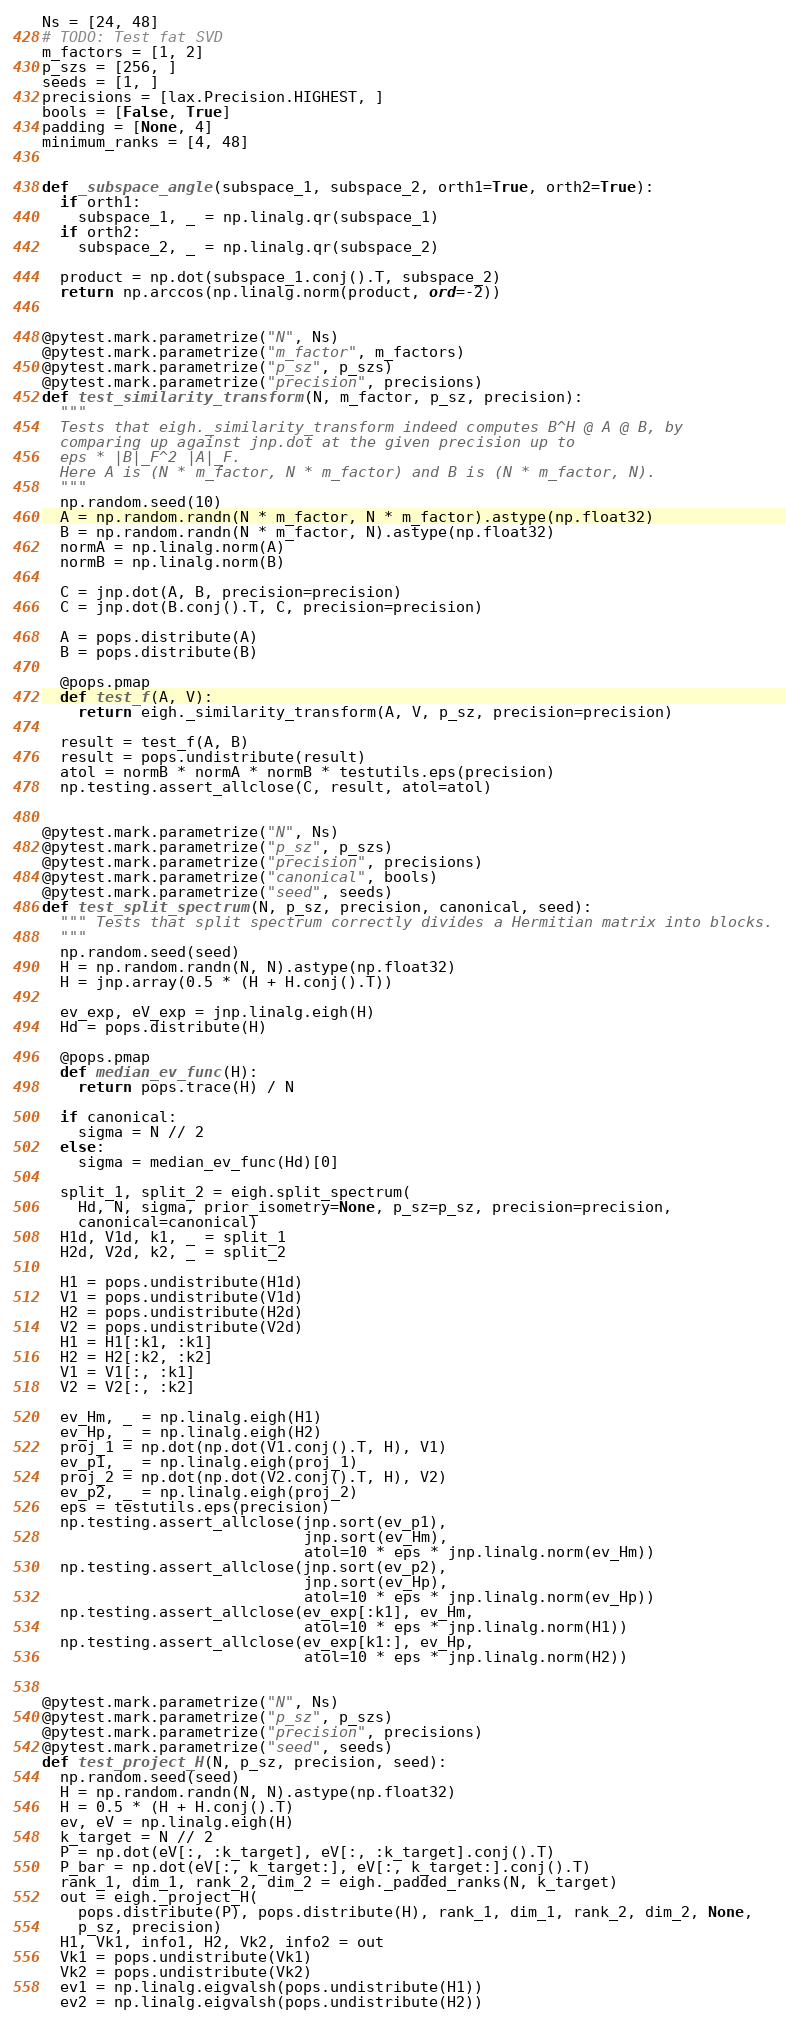<code> <loc_0><loc_0><loc_500><loc_500><_Python_>Ns = [24, 48]
# TODO: Test fat SVD
m_factors = [1, 2]
p_szs = [256, ]
seeds = [1, ]
precisions = [lax.Precision.HIGHEST, ]
bools = [False, True]
padding = [None, 4]
minimum_ranks = [4, 48]


def _subspace_angle(subspace_1, subspace_2, orth1=True, orth2=True):
  if orth1:
    subspace_1, _ = np.linalg.qr(subspace_1)
  if orth2:
    subspace_2, _ = np.linalg.qr(subspace_2)

  product = np.dot(subspace_1.conj().T, subspace_2)
  return np.arccos(np.linalg.norm(product, ord=-2))


@pytest.mark.parametrize("N", Ns)
@pytest.mark.parametrize("m_factor", m_factors)
@pytest.mark.parametrize("p_sz", p_szs)
@pytest.mark.parametrize("precision", precisions)
def test_similarity_transform(N, m_factor, p_sz, precision):
  """
  Tests that eigh._similarity_transform indeed computes B^H @ A @ B, by
  comparing up against jnp.dot at the given precision up to
  eps * |B|_F^2 |A|_F.
  Here A is (N * m_factor, N * m_factor) and B is (N * m_factor, N).
  """
  np.random.seed(10)
  A = np.random.randn(N * m_factor, N * m_factor).astype(np.float32)
  B = np.random.randn(N * m_factor, N).astype(np.float32)
  normA = np.linalg.norm(A)
  normB = np.linalg.norm(B)

  C = jnp.dot(A, B, precision=precision)
  C = jnp.dot(B.conj().T, C, precision=precision)

  A = pops.distribute(A)
  B = pops.distribute(B)

  @pops.pmap
  def test_f(A, V):
    return eigh._similarity_transform(A, V, p_sz, precision=precision)

  result = test_f(A, B)
  result = pops.undistribute(result)
  atol = normB * normA * normB * testutils.eps(precision)
  np.testing.assert_allclose(C, result, atol=atol)


@pytest.mark.parametrize("N", Ns)
@pytest.mark.parametrize("p_sz", p_szs)
@pytest.mark.parametrize("precision", precisions)
@pytest.mark.parametrize("canonical", bools)
@pytest.mark.parametrize("seed", seeds)
def test_split_spectrum(N, p_sz, precision, canonical, seed):
  """ Tests that split spectrum correctly divides a Hermitian matrix into blocks.
  """
  np.random.seed(seed)
  H = np.random.randn(N, N).astype(np.float32)
  H = jnp.array(0.5 * (H + H.conj().T))

  ev_exp, eV_exp = jnp.linalg.eigh(H)
  Hd = pops.distribute(H)

  @pops.pmap
  def median_ev_func(H):
    return pops.trace(H) / N

  if canonical:
    sigma = N // 2
  else:
    sigma = median_ev_func(Hd)[0]

  split_1, split_2 = eigh.split_spectrum(
    Hd, N, sigma, prior_isometry=None, p_sz=p_sz, precision=precision,
    canonical=canonical)
  H1d, V1d, k1, _ = split_1
  H2d, V2d, k2, _ = split_2

  H1 = pops.undistribute(H1d)
  V1 = pops.undistribute(V1d)
  H2 = pops.undistribute(H2d)
  V2 = pops.undistribute(V2d)
  H1 = H1[:k1, :k1]
  H2 = H2[:k2, :k2]
  V1 = V1[:, :k1]
  V2 = V2[:, :k2]

  ev_Hm, _ = np.linalg.eigh(H1)
  ev_Hp, _ = np.linalg.eigh(H2)
  proj_1 = np.dot(np.dot(V1.conj().T, H), V1)
  ev_p1, _ = np.linalg.eigh(proj_1)
  proj_2 = np.dot(np.dot(V2.conj().T, H), V2)
  ev_p2, _ = np.linalg.eigh(proj_2)
  eps = testutils.eps(precision)
  np.testing.assert_allclose(jnp.sort(ev_p1),
                             jnp.sort(ev_Hm),
                             atol=10 * eps * jnp.linalg.norm(ev_Hm))
  np.testing.assert_allclose(jnp.sort(ev_p2),
                             jnp.sort(ev_Hp),
                             atol=10 * eps * jnp.linalg.norm(ev_Hp))
  np.testing.assert_allclose(ev_exp[:k1], ev_Hm,
                             atol=10 * eps * jnp.linalg.norm(H1))
  np.testing.assert_allclose(ev_exp[k1:], ev_Hp,
                             atol=10 * eps * jnp.linalg.norm(H2))


@pytest.mark.parametrize("N", Ns)
@pytest.mark.parametrize("p_sz", p_szs)
@pytest.mark.parametrize("precision", precisions)
@pytest.mark.parametrize("seed", seeds)
def test_project_H(N, p_sz, precision, seed):
  np.random.seed(seed)
  H = np.random.randn(N, N).astype(np.float32)
  H = 0.5 * (H + H.conj().T)
  ev, eV = np.linalg.eigh(H)
  k_target = N // 2
  P = np.dot(eV[:, :k_target], eV[:, :k_target].conj().T)
  P_bar = np.dot(eV[:, k_target:], eV[:, k_target:].conj().T)
  rank_1, dim_1, rank_2, dim_2 = eigh._padded_ranks(N, k_target)
  out = eigh._project_H(
    pops.distribute(P), pops.distribute(H), rank_1, dim_1, rank_2, dim_2, None,
    p_sz, precision)
  H1, Vk1, info1, H2, Vk2, info2 = out
  Vk1 = pops.undistribute(Vk1)
  Vk2 = pops.undistribute(Vk2)
  ev1 = np.linalg.eigvalsh(pops.undistribute(H1))
  ev2 = np.linalg.eigvalsh(pops.undistribute(H2))</code> 